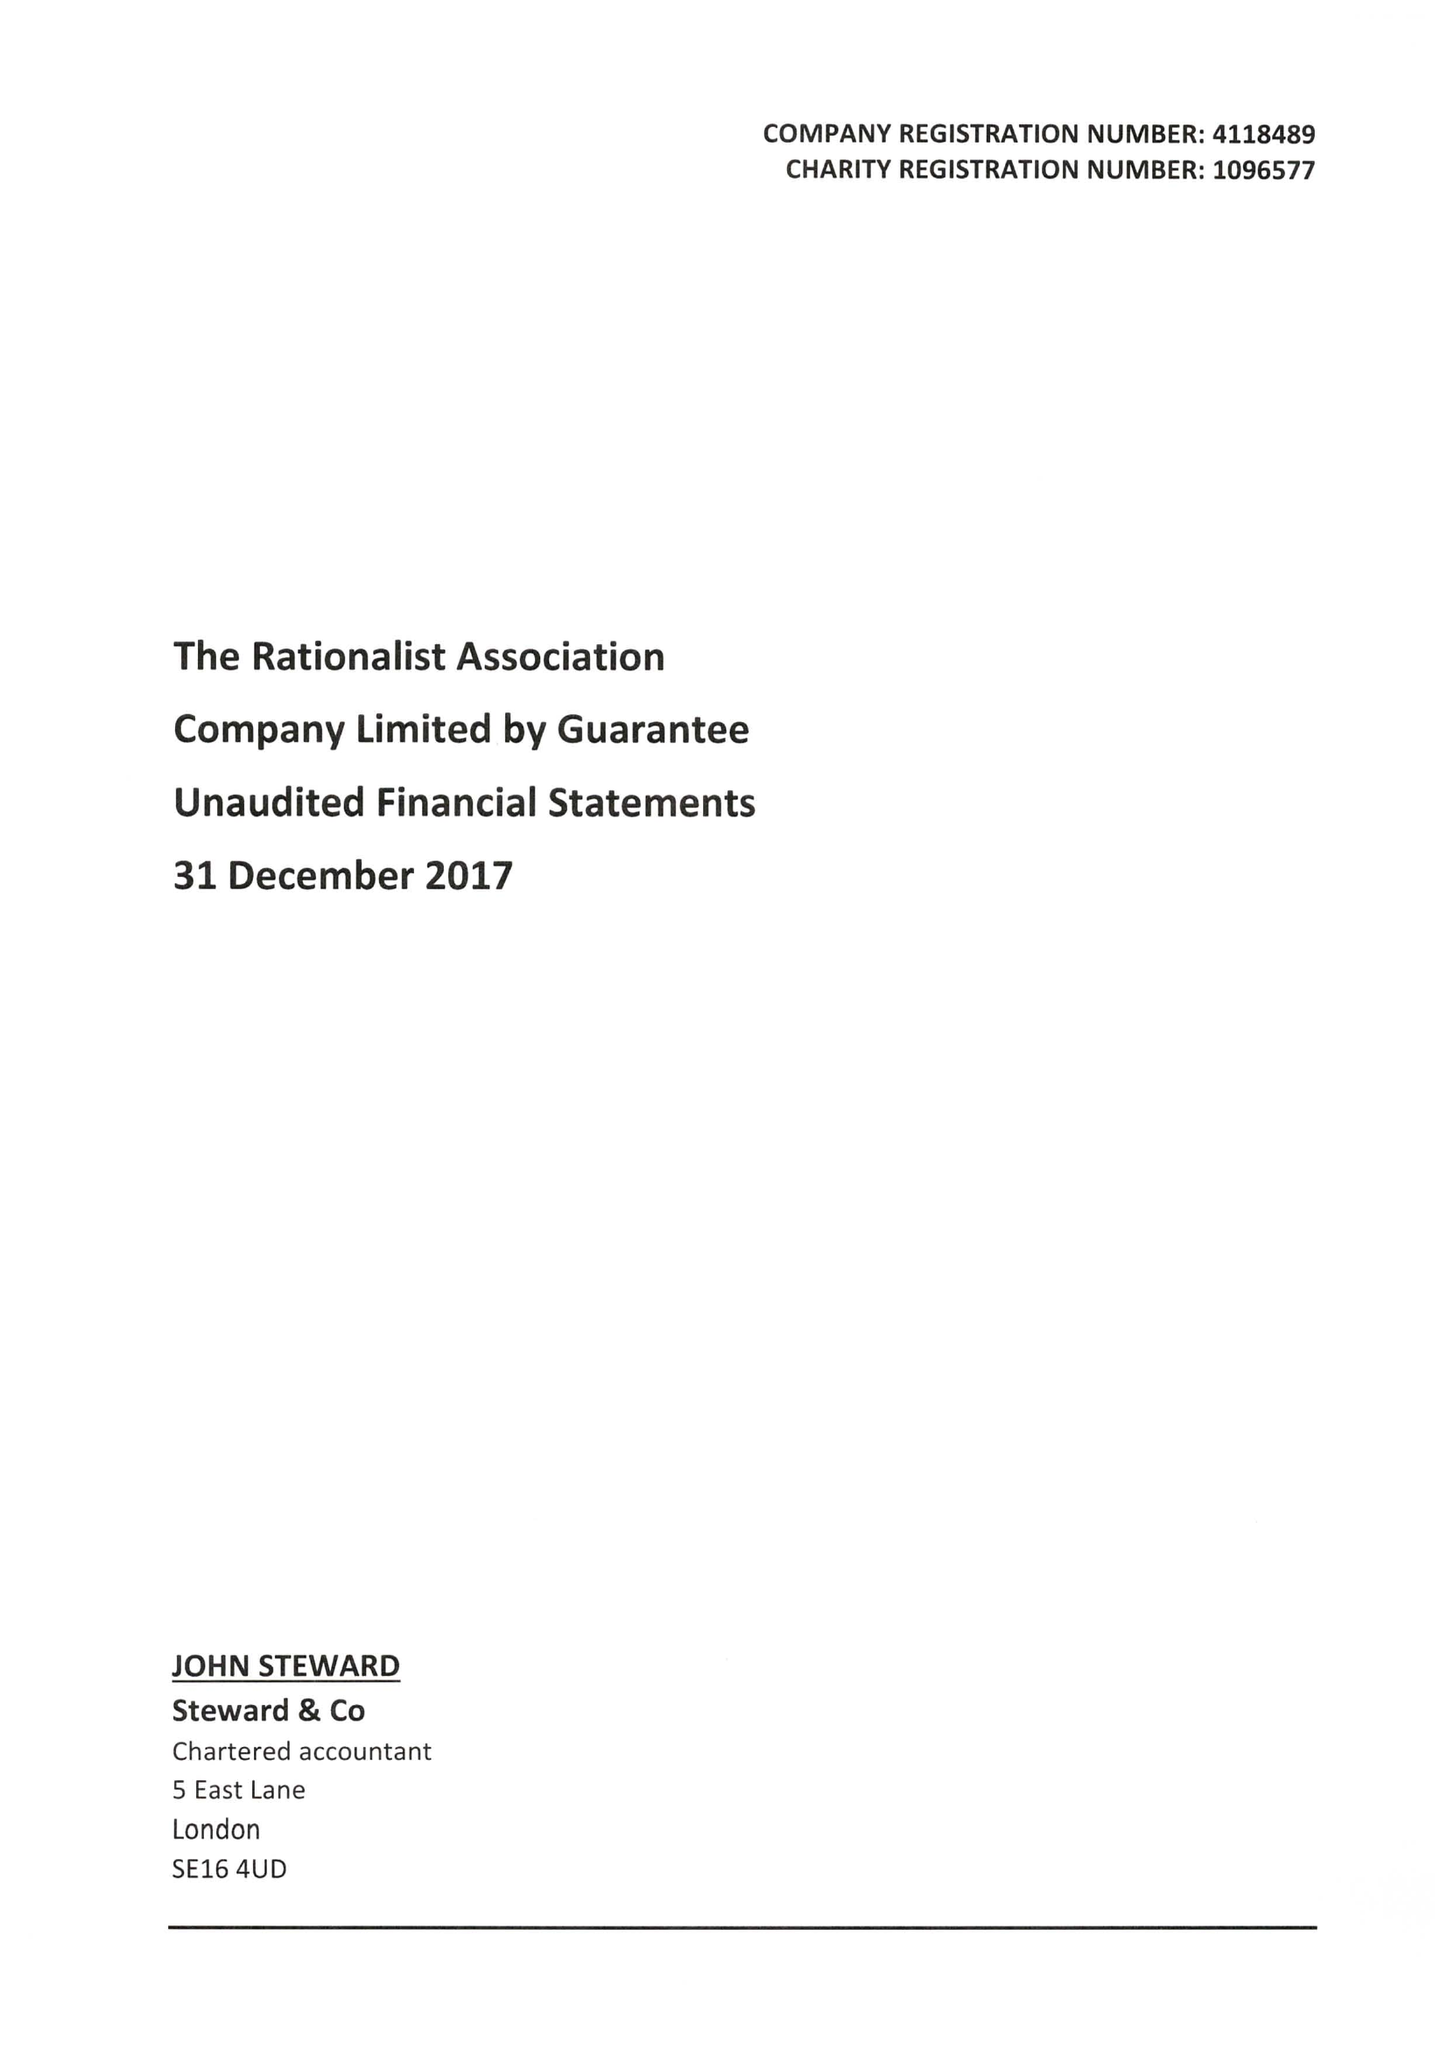What is the value for the address__postcode?
Answer the question using a single word or phrase. E2 9DA 